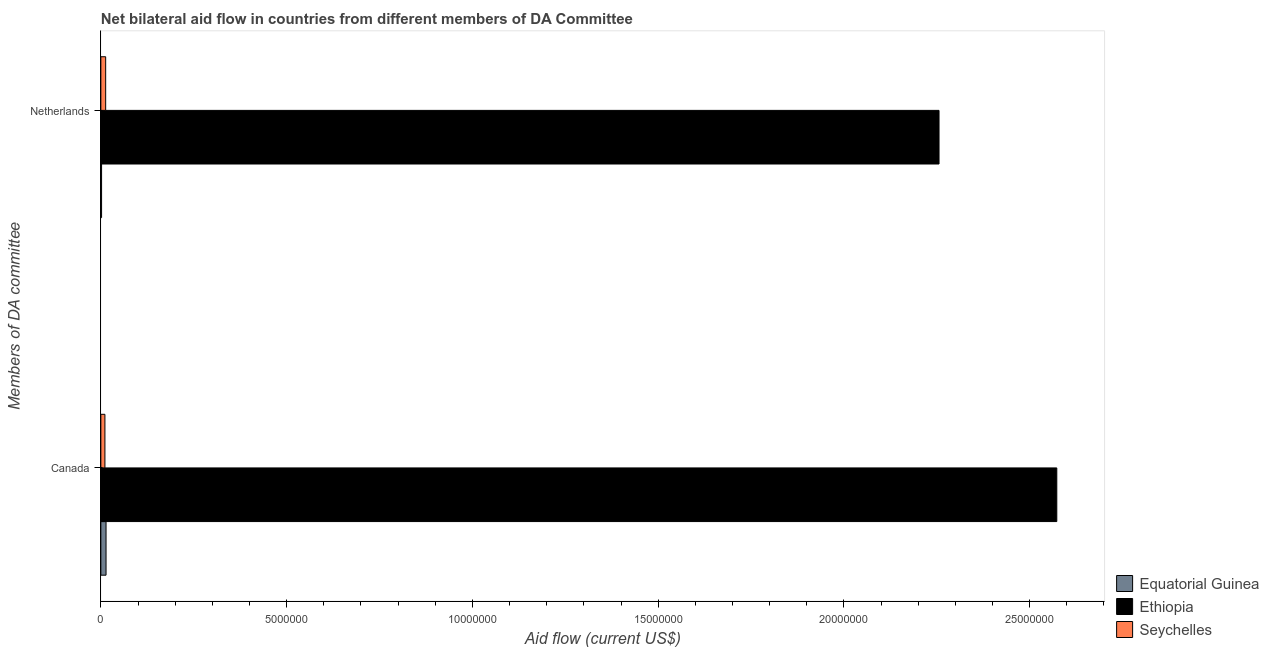How many groups of bars are there?
Offer a very short reply. 2. Are the number of bars per tick equal to the number of legend labels?
Offer a very short reply. Yes. What is the label of the 1st group of bars from the top?
Ensure brevity in your answer.  Netherlands. What is the amount of aid given by netherlands in Seychelles?
Provide a short and direct response. 1.30e+05. Across all countries, what is the maximum amount of aid given by canada?
Your answer should be very brief. 2.57e+07. Across all countries, what is the minimum amount of aid given by canada?
Your answer should be compact. 1.10e+05. In which country was the amount of aid given by netherlands maximum?
Make the answer very short. Ethiopia. In which country was the amount of aid given by canada minimum?
Keep it short and to the point. Seychelles. What is the total amount of aid given by canada in the graph?
Your answer should be compact. 2.60e+07. What is the difference between the amount of aid given by canada in Equatorial Guinea and that in Ethiopia?
Give a very brief answer. -2.56e+07. What is the difference between the amount of aid given by netherlands in Equatorial Guinea and the amount of aid given by canada in Seychelles?
Offer a terse response. -9.00e+04. What is the average amount of aid given by canada per country?
Provide a succinct answer. 8.66e+06. What is the difference between the amount of aid given by canada and amount of aid given by netherlands in Equatorial Guinea?
Provide a short and direct response. 1.20e+05. What is the ratio of the amount of aid given by canada in Seychelles to that in Equatorial Guinea?
Your answer should be very brief. 0.79. What does the 1st bar from the top in Canada represents?
Ensure brevity in your answer.  Seychelles. What does the 1st bar from the bottom in Netherlands represents?
Provide a short and direct response. Equatorial Guinea. How many bars are there?
Ensure brevity in your answer.  6. Are all the bars in the graph horizontal?
Ensure brevity in your answer.  Yes. How many countries are there in the graph?
Offer a very short reply. 3. What is the difference between two consecutive major ticks on the X-axis?
Keep it short and to the point. 5.00e+06. Are the values on the major ticks of X-axis written in scientific E-notation?
Your answer should be compact. No. Does the graph contain any zero values?
Your answer should be very brief. No. Where does the legend appear in the graph?
Your answer should be compact. Bottom right. What is the title of the graph?
Your answer should be very brief. Net bilateral aid flow in countries from different members of DA Committee. What is the label or title of the X-axis?
Your answer should be very brief. Aid flow (current US$). What is the label or title of the Y-axis?
Ensure brevity in your answer.  Members of DA committee. What is the Aid flow (current US$) in Ethiopia in Canada?
Your answer should be very brief. 2.57e+07. What is the Aid flow (current US$) in Equatorial Guinea in Netherlands?
Provide a succinct answer. 2.00e+04. What is the Aid flow (current US$) of Ethiopia in Netherlands?
Your answer should be compact. 2.26e+07. What is the Aid flow (current US$) in Seychelles in Netherlands?
Offer a terse response. 1.30e+05. Across all Members of DA committee, what is the maximum Aid flow (current US$) of Ethiopia?
Offer a terse response. 2.57e+07. Across all Members of DA committee, what is the maximum Aid flow (current US$) of Seychelles?
Give a very brief answer. 1.30e+05. Across all Members of DA committee, what is the minimum Aid flow (current US$) in Ethiopia?
Provide a succinct answer. 2.26e+07. What is the total Aid flow (current US$) in Ethiopia in the graph?
Offer a terse response. 4.83e+07. What is the difference between the Aid flow (current US$) of Ethiopia in Canada and that in Netherlands?
Provide a succinct answer. 3.17e+06. What is the difference between the Aid flow (current US$) of Seychelles in Canada and that in Netherlands?
Give a very brief answer. -2.00e+04. What is the difference between the Aid flow (current US$) in Equatorial Guinea in Canada and the Aid flow (current US$) in Ethiopia in Netherlands?
Provide a succinct answer. -2.24e+07. What is the difference between the Aid flow (current US$) of Ethiopia in Canada and the Aid flow (current US$) of Seychelles in Netherlands?
Your answer should be very brief. 2.56e+07. What is the average Aid flow (current US$) in Equatorial Guinea per Members of DA committee?
Make the answer very short. 8.00e+04. What is the average Aid flow (current US$) in Ethiopia per Members of DA committee?
Offer a very short reply. 2.41e+07. What is the average Aid flow (current US$) in Seychelles per Members of DA committee?
Give a very brief answer. 1.20e+05. What is the difference between the Aid flow (current US$) of Equatorial Guinea and Aid flow (current US$) of Ethiopia in Canada?
Keep it short and to the point. -2.56e+07. What is the difference between the Aid flow (current US$) in Ethiopia and Aid flow (current US$) in Seychelles in Canada?
Keep it short and to the point. 2.56e+07. What is the difference between the Aid flow (current US$) of Equatorial Guinea and Aid flow (current US$) of Ethiopia in Netherlands?
Keep it short and to the point. -2.25e+07. What is the difference between the Aid flow (current US$) in Equatorial Guinea and Aid flow (current US$) in Seychelles in Netherlands?
Offer a terse response. -1.10e+05. What is the difference between the Aid flow (current US$) of Ethiopia and Aid flow (current US$) of Seychelles in Netherlands?
Provide a short and direct response. 2.24e+07. What is the ratio of the Aid flow (current US$) in Equatorial Guinea in Canada to that in Netherlands?
Give a very brief answer. 7. What is the ratio of the Aid flow (current US$) of Ethiopia in Canada to that in Netherlands?
Your answer should be compact. 1.14. What is the ratio of the Aid flow (current US$) in Seychelles in Canada to that in Netherlands?
Your answer should be very brief. 0.85. What is the difference between the highest and the second highest Aid flow (current US$) in Ethiopia?
Provide a succinct answer. 3.17e+06. What is the difference between the highest and the second highest Aid flow (current US$) of Seychelles?
Offer a very short reply. 2.00e+04. What is the difference between the highest and the lowest Aid flow (current US$) of Equatorial Guinea?
Keep it short and to the point. 1.20e+05. What is the difference between the highest and the lowest Aid flow (current US$) in Ethiopia?
Offer a very short reply. 3.17e+06. 